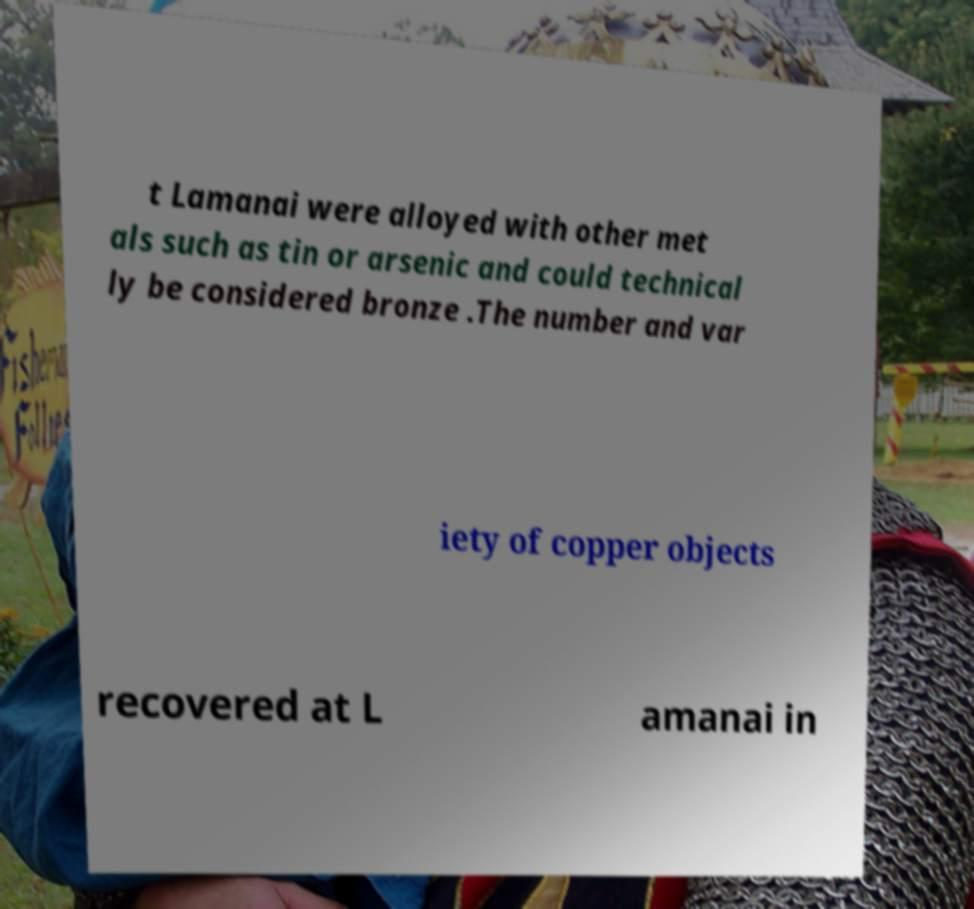Could you assist in decoding the text presented in this image and type it out clearly? t Lamanai were alloyed with other met als such as tin or arsenic and could technical ly be considered bronze .The number and var iety of copper objects recovered at L amanai in 